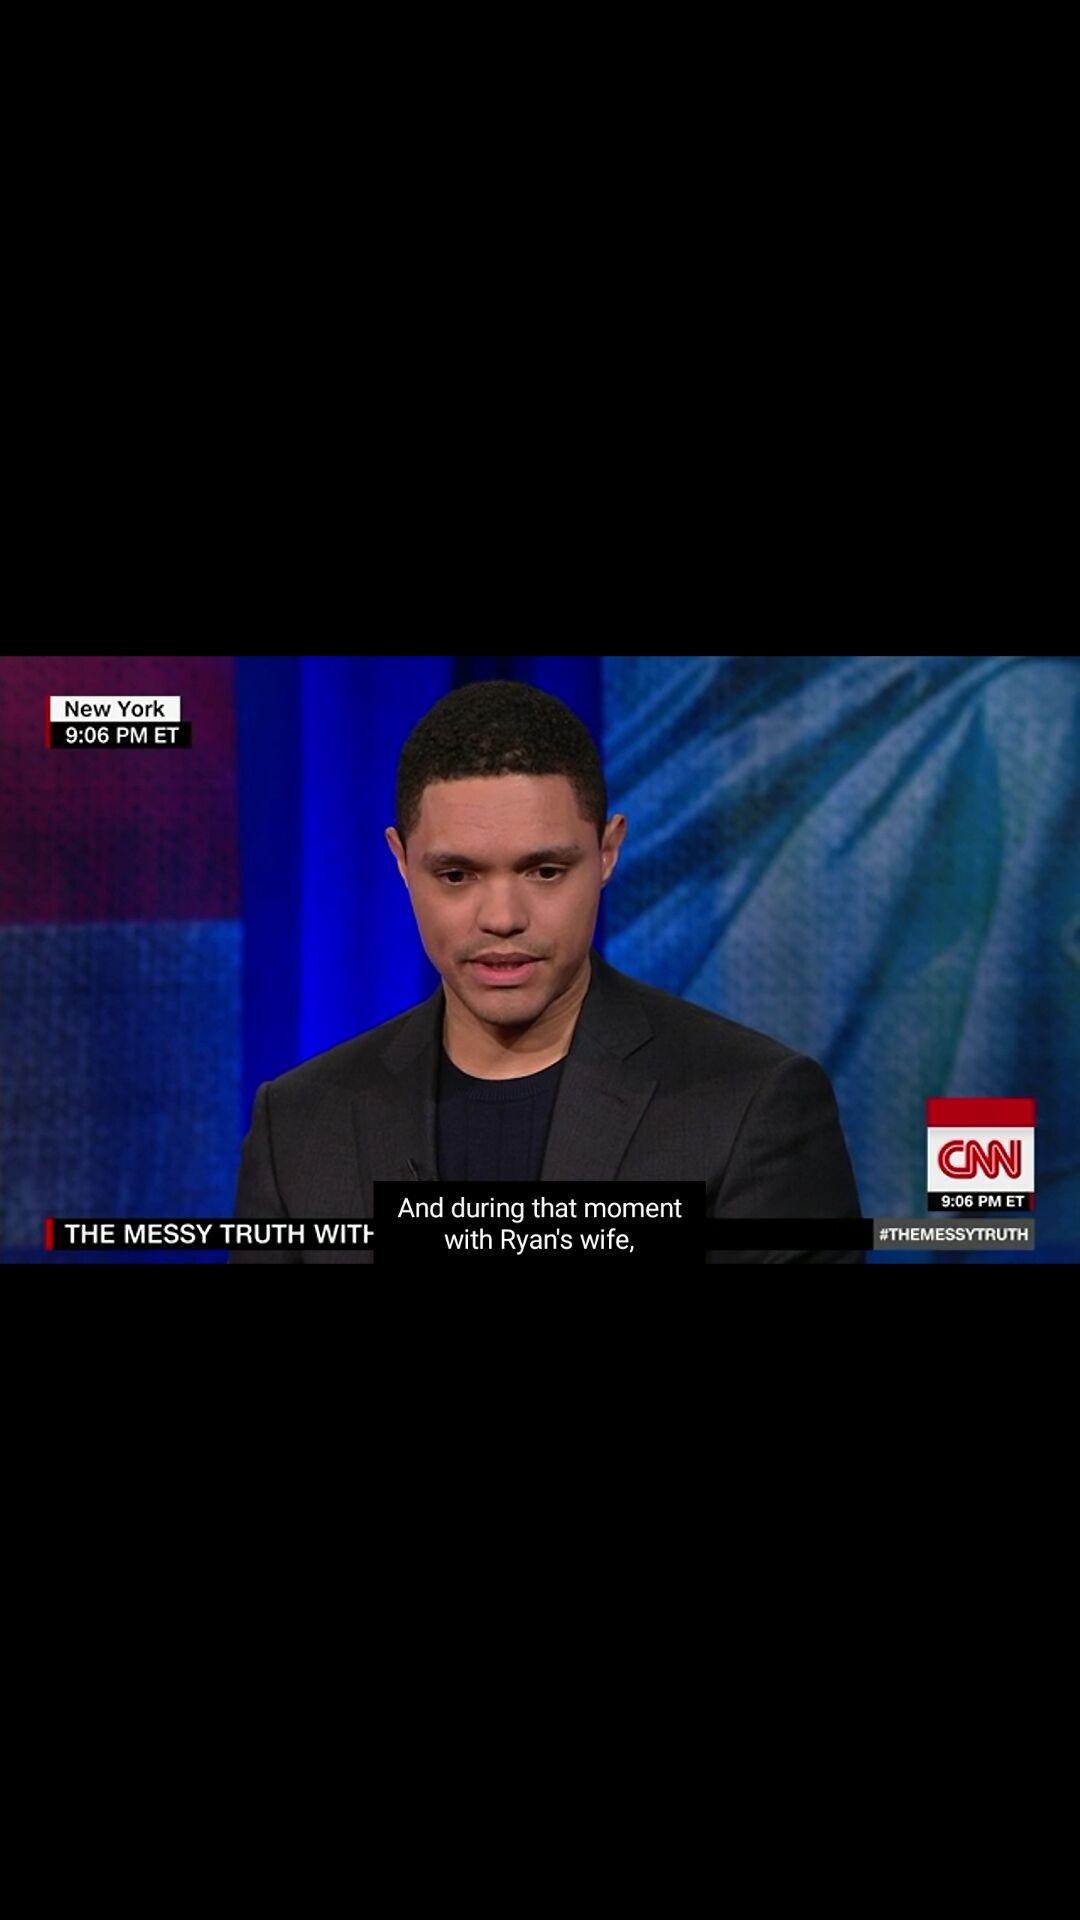How many hours is the longest video?
Answer the question using a single word or phrase. 4 